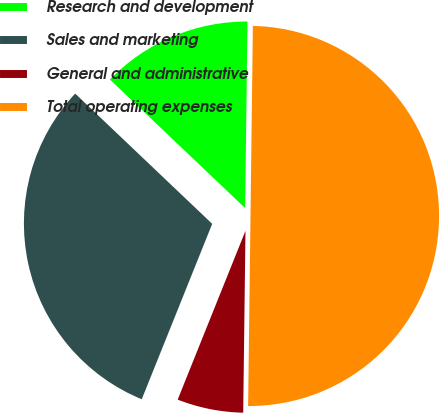Convert chart to OTSL. <chart><loc_0><loc_0><loc_500><loc_500><pie_chart><fcel>Research and development<fcel>Sales and marketing<fcel>General and administrative<fcel>Total operating expenses<nl><fcel>13.1%<fcel>31.02%<fcel>5.88%<fcel>50.0%<nl></chart> 